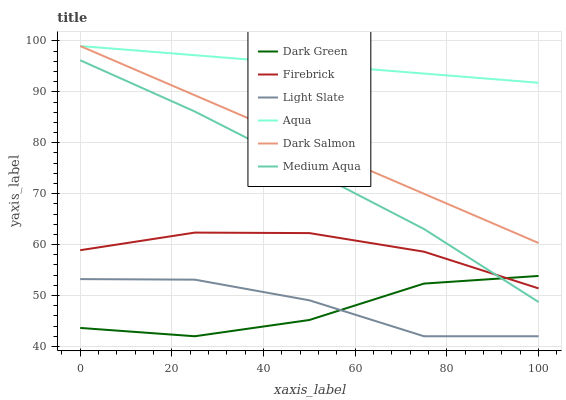Does Dark Green have the minimum area under the curve?
Answer yes or no. Yes. Does Aqua have the maximum area under the curve?
Answer yes or no. Yes. Does Firebrick have the minimum area under the curve?
Answer yes or no. No. Does Firebrick have the maximum area under the curve?
Answer yes or no. No. Is Dark Salmon the smoothest?
Answer yes or no. Yes. Is Dark Green the roughest?
Answer yes or no. Yes. Is Firebrick the smoothest?
Answer yes or no. No. Is Firebrick the roughest?
Answer yes or no. No. Does Light Slate have the lowest value?
Answer yes or no. Yes. Does Firebrick have the lowest value?
Answer yes or no. No. Does Dark Salmon have the highest value?
Answer yes or no. Yes. Does Firebrick have the highest value?
Answer yes or no. No. Is Dark Green less than Dark Salmon?
Answer yes or no. Yes. Is Aqua greater than Light Slate?
Answer yes or no. Yes. Does Aqua intersect Dark Salmon?
Answer yes or no. Yes. Is Aqua less than Dark Salmon?
Answer yes or no. No. Is Aqua greater than Dark Salmon?
Answer yes or no. No. Does Dark Green intersect Dark Salmon?
Answer yes or no. No. 